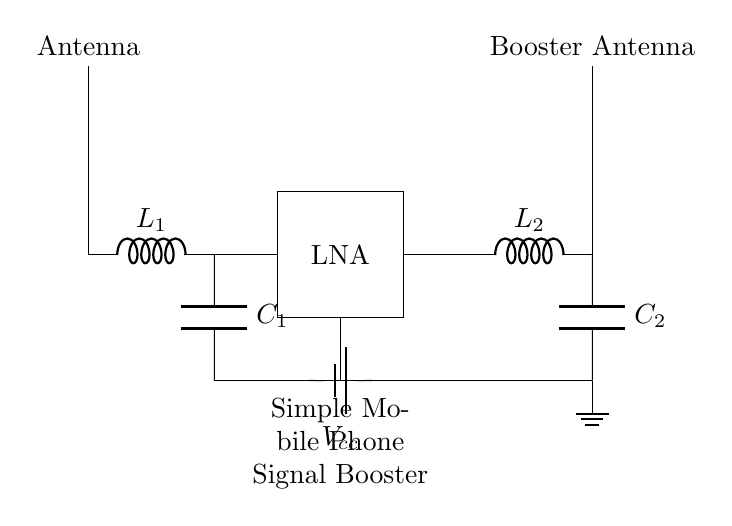What type of circuit is represented? The circuit shown is a simple mobile phone signal booster, which is designed to enhance signal strength for mobile connectivity.
Answer: mobile phone signal booster What is the role of the LNA in this circuit? The Low Noise Amplifier (LNA) amplifies the weak signals received from the antenna before they are further processed, ensuring that the signal strength is improved for better quality.
Answer: amplify signals What is the power supply voltage indicated in the circuit? The voltage from the power supply is denoted as Vcc, but the exact numerical value is not specified in the diagram. Hence, it's labeled only.
Answer: Vcc How many inductors are present in the circuit? There are two inductors, L1 and L2, that are part of the input and output matching networks respectively.
Answer: two What connects the ground to this circuit? The ground in the circuit is connected through a line leading from the output matching network down to the ground symbol, indicating a common reference point for the circuit.
Answer: ground connection What type of components are both antennas in the circuit? Both antennas are represented as a single component type called an antenna, which is essential for receiving and transmitting the signals.
Answer: antennas Why is an output matching network included in the design? The output matching network, consisting of L2 and C2, is included to ensure that the impedance is matched for effective power transfer to the booster antenna, thus enhancing overall performance.
Answer: effective power transfer 